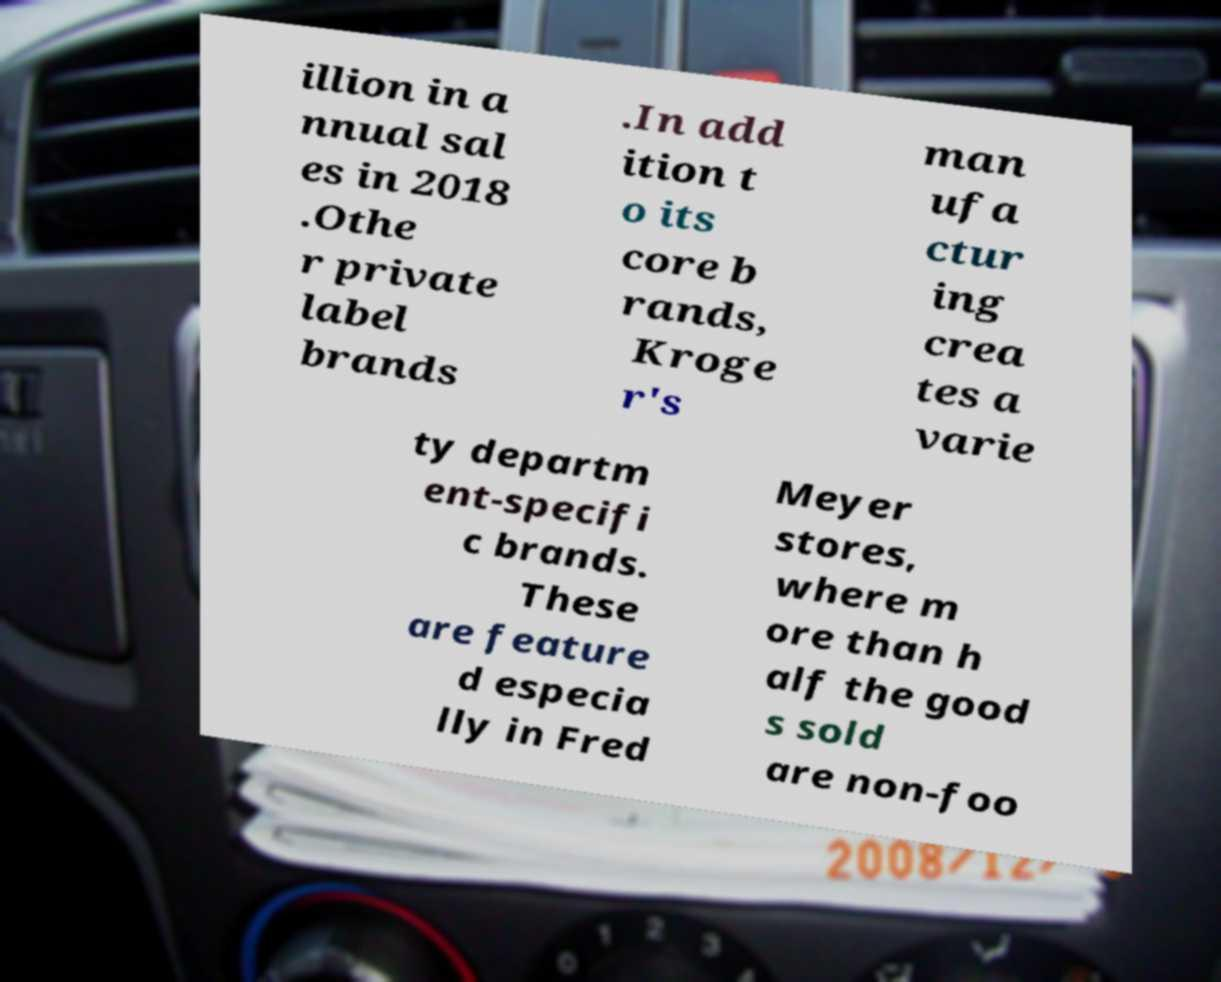Please identify and transcribe the text found in this image. illion in a nnual sal es in 2018 .Othe r private label brands .In add ition t o its core b rands, Kroge r's man ufa ctur ing crea tes a varie ty departm ent-specifi c brands. These are feature d especia lly in Fred Meyer stores, where m ore than h alf the good s sold are non-foo 